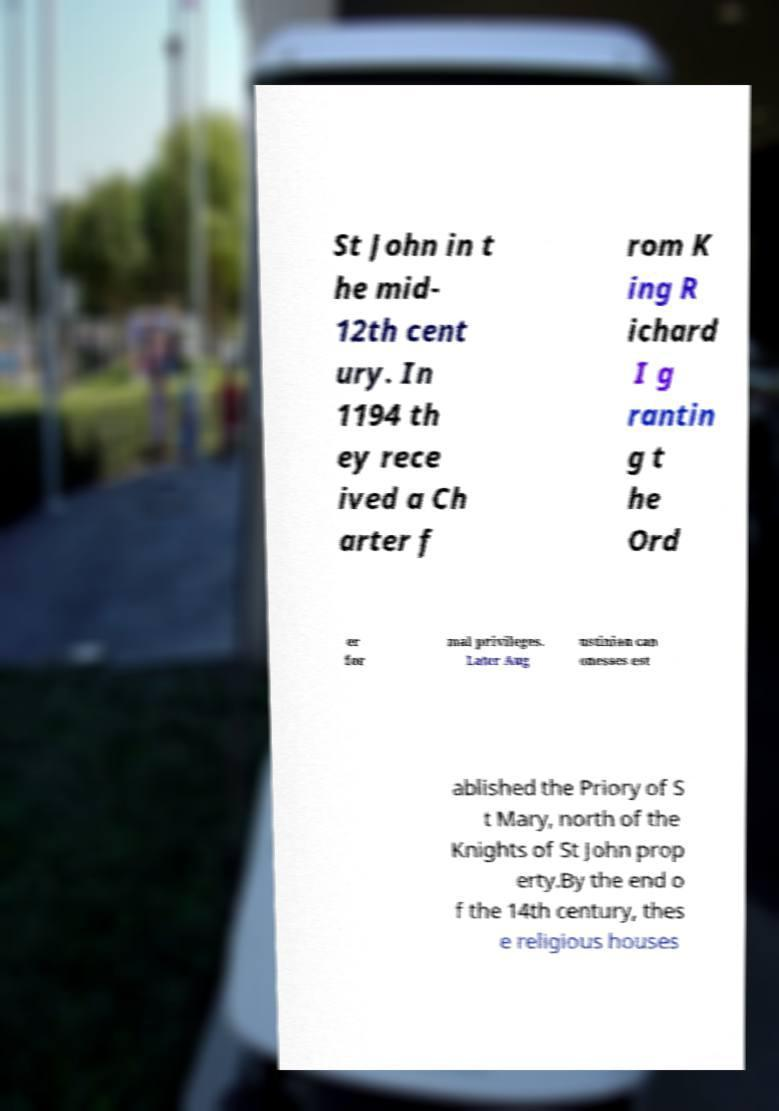Could you assist in decoding the text presented in this image and type it out clearly? St John in t he mid- 12th cent ury. In 1194 th ey rece ived a Ch arter f rom K ing R ichard I g rantin g t he Ord er for mal privileges. Later Aug ustinian can onesses est ablished the Priory of S t Mary, north of the Knights of St John prop erty.By the end o f the 14th century, thes e religious houses 